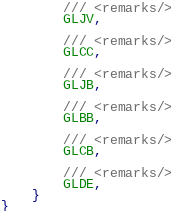Convert code to text. <code><loc_0><loc_0><loc_500><loc_500><_C#_>        /// <remarks/>
        GLJV,
        
        /// <remarks/>
        GLCC,
        
        /// <remarks/>
        GLJB,
        
        /// <remarks/>
        GLBB,
        
        /// <remarks/>
        GLCB,
        
        /// <remarks/>
        GLDE,
    }
}
</code> 